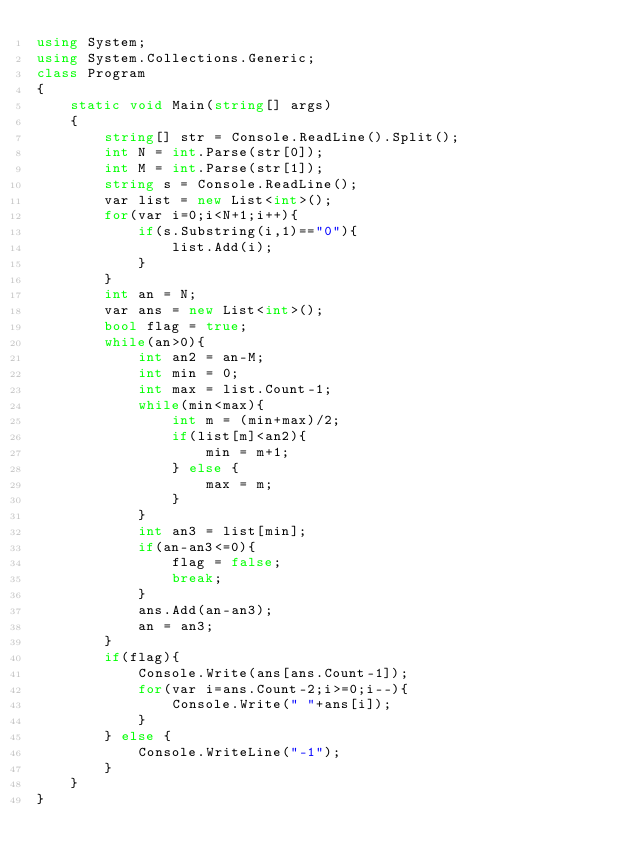<code> <loc_0><loc_0><loc_500><loc_500><_C#_>using System;
using System.Collections.Generic;
class Program
{
	static void Main(string[] args)
	{
		string[] str = Console.ReadLine().Split();
		int N = int.Parse(str[0]);
		int M = int.Parse(str[1]);
		string s = Console.ReadLine();
		var list = new List<int>();
		for(var i=0;i<N+1;i++){
			if(s.Substring(i,1)=="0"){
				list.Add(i);
			}
		}
		int an = N;
		var ans = new List<int>();
		bool flag = true;
		while(an>0){
			int an2 = an-M;
			int min = 0;
			int max = list.Count-1;
			while(min<max){
				int m = (min+max)/2;
				if(list[m]<an2){
					min = m+1;
				} else {
					max = m;
				}
			}
			int an3 = list[min];
			if(an-an3<=0){
				flag = false;
				break;
			}
			ans.Add(an-an3);
          	an = an3;
		}
		if(flag){
			Console.Write(ans[ans.Count-1]);
			for(var i=ans.Count-2;i>=0;i--){
				Console.Write(" "+ans[i]);
			}
		} else {
			Console.WriteLine("-1");
		}
	}
}</code> 